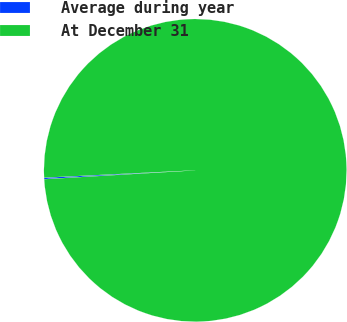Convert chart. <chart><loc_0><loc_0><loc_500><loc_500><pie_chart><fcel>Average during year<fcel>At December 31<nl><fcel>0.16%<fcel>99.84%<nl></chart> 